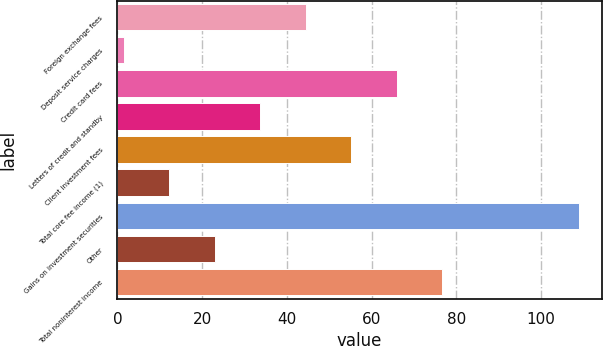<chart> <loc_0><loc_0><loc_500><loc_500><bar_chart><fcel>Foreign exchange fees<fcel>Deposit service charges<fcel>Credit card fees<fcel>Letters of credit and standby<fcel>Client investment fees<fcel>Total core fee income (1)<fcel>Gains on investment securities<fcel>Other<fcel>Total noninterest income<nl><fcel>44.46<fcel>1.5<fcel>65.94<fcel>33.72<fcel>55.2<fcel>12.24<fcel>108.9<fcel>22.98<fcel>76.68<nl></chart> 